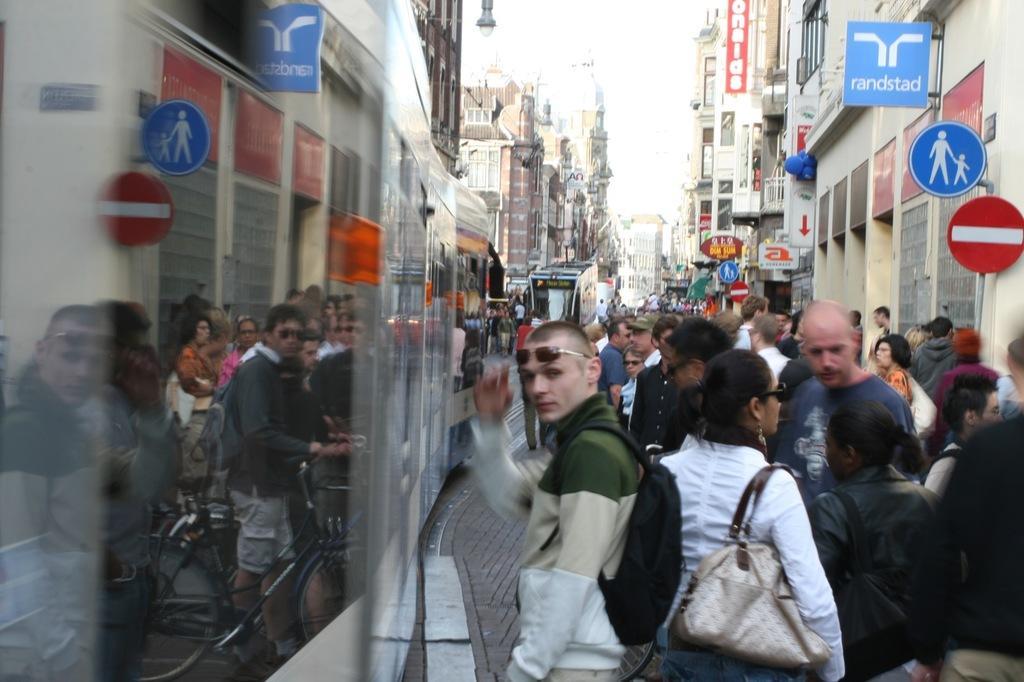Could you give a brief overview of what you see in this image? Here in this picture we can see number of people standing on the road over there and they are carrying bags and handbags and goggles with them and on the left side we can see a train present over there and we can see buildings present on either side over there and we can see hoardings present on the buildings and we can also see sign boards over there and we can see light posts present over there. 